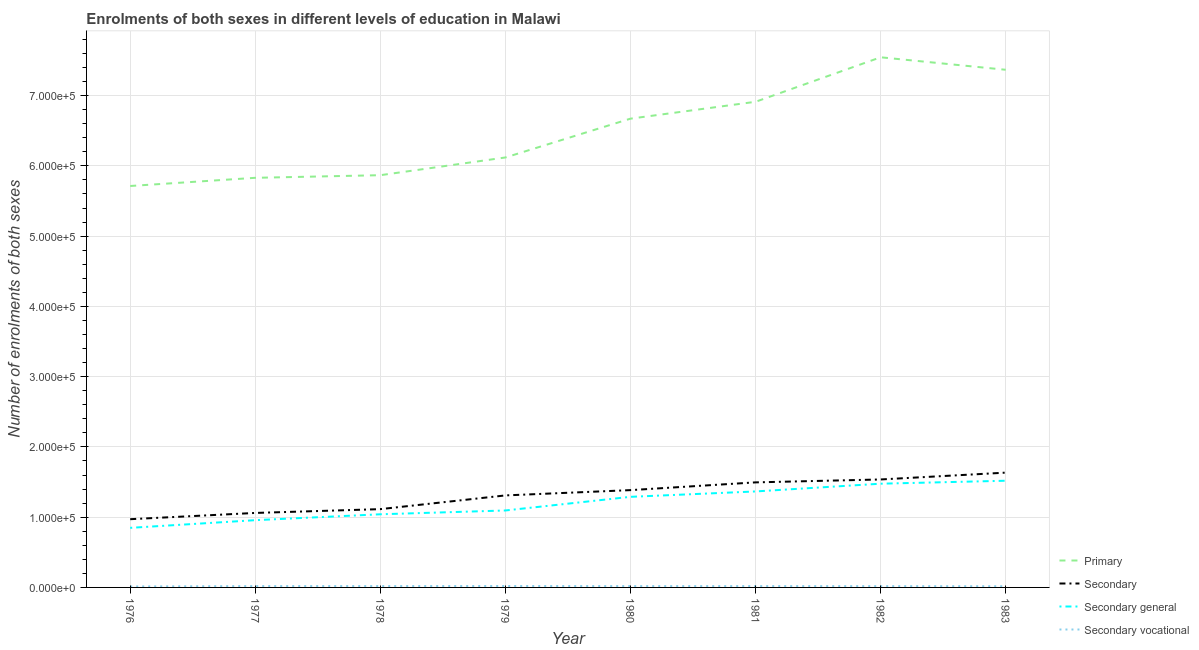Is the number of lines equal to the number of legend labels?
Provide a short and direct response. Yes. What is the number of enrolments in primary education in 1982?
Give a very brief answer. 7.55e+05. Across all years, what is the maximum number of enrolments in secondary general education?
Your response must be concise. 1.52e+05. Across all years, what is the minimum number of enrolments in secondary vocational education?
Provide a succinct answer. 1392. In which year was the number of enrolments in secondary education maximum?
Make the answer very short. 1983. In which year was the number of enrolments in secondary education minimum?
Your response must be concise. 1976. What is the total number of enrolments in secondary general education in the graph?
Offer a very short reply. 9.59e+05. What is the difference between the number of enrolments in secondary vocational education in 1980 and that in 1983?
Your response must be concise. 187. What is the difference between the number of enrolments in secondary general education in 1982 and the number of enrolments in secondary education in 1976?
Your answer should be compact. 5.05e+04. What is the average number of enrolments in secondary education per year?
Your answer should be very brief. 1.31e+05. In the year 1978, what is the difference between the number of enrolments in primary education and number of enrolments in secondary general education?
Provide a short and direct response. 4.83e+05. What is the ratio of the number of enrolments in secondary vocational education in 1977 to that in 1979?
Ensure brevity in your answer.  0.94. Is the number of enrolments in primary education in 1977 less than that in 1981?
Provide a succinct answer. Yes. What is the difference between the highest and the second highest number of enrolments in secondary vocational education?
Give a very brief answer. 108. What is the difference between the highest and the lowest number of enrolments in secondary general education?
Keep it short and to the point. 6.71e+04. In how many years, is the number of enrolments in primary education greater than the average number of enrolments in primary education taken over all years?
Ensure brevity in your answer.  4. Is the sum of the number of enrolments in secondary education in 1976 and 1982 greater than the maximum number of enrolments in secondary vocational education across all years?
Offer a very short reply. Yes. Is it the case that in every year, the sum of the number of enrolments in primary education and number of enrolments in secondary education is greater than the number of enrolments in secondary general education?
Your answer should be very brief. Yes. Does the number of enrolments in secondary education monotonically increase over the years?
Your answer should be compact. Yes. How many lines are there?
Your answer should be very brief. 4. How many years are there in the graph?
Your answer should be compact. 8. Does the graph contain any zero values?
Your response must be concise. No. How many legend labels are there?
Your response must be concise. 4. What is the title of the graph?
Your answer should be compact. Enrolments of both sexes in different levels of education in Malawi. Does "Overall level" appear as one of the legend labels in the graph?
Make the answer very short. No. What is the label or title of the Y-axis?
Make the answer very short. Number of enrolments of both sexes. What is the Number of enrolments of both sexes in Primary in 1976?
Offer a very short reply. 5.71e+05. What is the Number of enrolments of both sexes in Secondary in 1976?
Keep it short and to the point. 9.71e+04. What is the Number of enrolments of both sexes of Secondary general in 1976?
Offer a very short reply. 8.48e+04. What is the Number of enrolments of both sexes in Secondary vocational in 1976?
Provide a short and direct response. 1392. What is the Number of enrolments of both sexes of Primary in 1977?
Offer a very short reply. 5.83e+05. What is the Number of enrolments of both sexes in Secondary in 1977?
Your answer should be compact. 1.06e+05. What is the Number of enrolments of both sexes in Secondary general in 1977?
Your answer should be very brief. 9.57e+04. What is the Number of enrolments of both sexes in Secondary vocational in 1977?
Your response must be concise. 1905. What is the Number of enrolments of both sexes of Primary in 1978?
Give a very brief answer. 5.87e+05. What is the Number of enrolments of both sexes of Secondary in 1978?
Offer a terse response. 1.11e+05. What is the Number of enrolments of both sexes in Secondary general in 1978?
Your answer should be compact. 1.04e+05. What is the Number of enrolments of both sexes of Secondary vocational in 1978?
Your answer should be very brief. 1915. What is the Number of enrolments of both sexes of Primary in 1979?
Provide a succinct answer. 6.12e+05. What is the Number of enrolments of both sexes in Secondary in 1979?
Make the answer very short. 1.31e+05. What is the Number of enrolments of both sexes in Secondary general in 1979?
Your response must be concise. 1.10e+05. What is the Number of enrolments of both sexes of Secondary vocational in 1979?
Provide a succinct answer. 2023. What is the Number of enrolments of both sexes of Primary in 1980?
Keep it short and to the point. 6.67e+05. What is the Number of enrolments of both sexes of Secondary in 1980?
Make the answer very short. 1.38e+05. What is the Number of enrolments of both sexes in Secondary general in 1980?
Keep it short and to the point. 1.29e+05. What is the Number of enrolments of both sexes of Secondary vocational in 1980?
Provide a succinct answer. 1875. What is the Number of enrolments of both sexes in Primary in 1981?
Give a very brief answer. 6.91e+05. What is the Number of enrolments of both sexes in Secondary in 1981?
Offer a very short reply. 1.50e+05. What is the Number of enrolments of both sexes of Secondary general in 1981?
Keep it short and to the point. 1.37e+05. What is the Number of enrolments of both sexes in Secondary vocational in 1981?
Provide a succinct answer. 1888. What is the Number of enrolments of both sexes of Primary in 1982?
Your response must be concise. 7.55e+05. What is the Number of enrolments of both sexes in Secondary in 1982?
Offer a terse response. 1.54e+05. What is the Number of enrolments of both sexes in Secondary general in 1982?
Keep it short and to the point. 1.48e+05. What is the Number of enrolments of both sexes of Secondary vocational in 1982?
Provide a succinct answer. 1814. What is the Number of enrolments of both sexes of Primary in 1983?
Offer a terse response. 7.37e+05. What is the Number of enrolments of both sexes in Secondary in 1983?
Ensure brevity in your answer.  1.63e+05. What is the Number of enrolments of both sexes in Secondary general in 1983?
Your answer should be compact. 1.52e+05. What is the Number of enrolments of both sexes of Secondary vocational in 1983?
Provide a short and direct response. 1688. Across all years, what is the maximum Number of enrolments of both sexes of Primary?
Your response must be concise. 7.55e+05. Across all years, what is the maximum Number of enrolments of both sexes of Secondary?
Your answer should be very brief. 1.63e+05. Across all years, what is the maximum Number of enrolments of both sexes of Secondary general?
Ensure brevity in your answer.  1.52e+05. Across all years, what is the maximum Number of enrolments of both sexes of Secondary vocational?
Provide a short and direct response. 2023. Across all years, what is the minimum Number of enrolments of both sexes of Primary?
Give a very brief answer. 5.71e+05. Across all years, what is the minimum Number of enrolments of both sexes in Secondary?
Ensure brevity in your answer.  9.71e+04. Across all years, what is the minimum Number of enrolments of both sexes of Secondary general?
Provide a succinct answer. 8.48e+04. Across all years, what is the minimum Number of enrolments of both sexes of Secondary vocational?
Your response must be concise. 1392. What is the total Number of enrolments of both sexes in Primary in the graph?
Provide a short and direct response. 5.20e+06. What is the total Number of enrolments of both sexes in Secondary in the graph?
Provide a short and direct response. 1.05e+06. What is the total Number of enrolments of both sexes in Secondary general in the graph?
Provide a succinct answer. 9.59e+05. What is the total Number of enrolments of both sexes of Secondary vocational in the graph?
Offer a terse response. 1.45e+04. What is the difference between the Number of enrolments of both sexes of Primary in 1976 and that in 1977?
Offer a very short reply. -1.16e+04. What is the difference between the Number of enrolments of both sexes of Secondary in 1976 and that in 1977?
Your response must be concise. -8907. What is the difference between the Number of enrolments of both sexes of Secondary general in 1976 and that in 1977?
Keep it short and to the point. -1.09e+04. What is the difference between the Number of enrolments of both sexes of Secondary vocational in 1976 and that in 1977?
Ensure brevity in your answer.  -513. What is the difference between the Number of enrolments of both sexes in Primary in 1976 and that in 1978?
Offer a terse response. -1.54e+04. What is the difference between the Number of enrolments of both sexes of Secondary in 1976 and that in 1978?
Ensure brevity in your answer.  -1.43e+04. What is the difference between the Number of enrolments of both sexes in Secondary general in 1976 and that in 1978?
Offer a terse response. -1.93e+04. What is the difference between the Number of enrolments of both sexes in Secondary vocational in 1976 and that in 1978?
Give a very brief answer. -523. What is the difference between the Number of enrolments of both sexes in Primary in 1976 and that in 1979?
Provide a short and direct response. -4.06e+04. What is the difference between the Number of enrolments of both sexes in Secondary in 1976 and that in 1979?
Make the answer very short. -3.39e+04. What is the difference between the Number of enrolments of both sexes of Secondary general in 1976 and that in 1979?
Keep it short and to the point. -2.47e+04. What is the difference between the Number of enrolments of both sexes in Secondary vocational in 1976 and that in 1979?
Ensure brevity in your answer.  -631. What is the difference between the Number of enrolments of both sexes in Primary in 1976 and that in 1980?
Offer a terse response. -9.58e+04. What is the difference between the Number of enrolments of both sexes in Secondary in 1976 and that in 1980?
Ensure brevity in your answer.  -4.14e+04. What is the difference between the Number of enrolments of both sexes of Secondary general in 1976 and that in 1980?
Offer a terse response. -4.41e+04. What is the difference between the Number of enrolments of both sexes in Secondary vocational in 1976 and that in 1980?
Make the answer very short. -483. What is the difference between the Number of enrolments of both sexes of Primary in 1976 and that in 1981?
Your response must be concise. -1.20e+05. What is the difference between the Number of enrolments of both sexes of Secondary in 1976 and that in 1981?
Your response must be concise. -5.24e+04. What is the difference between the Number of enrolments of both sexes of Secondary general in 1976 and that in 1981?
Your response must be concise. -5.18e+04. What is the difference between the Number of enrolments of both sexes in Secondary vocational in 1976 and that in 1981?
Your answer should be very brief. -496. What is the difference between the Number of enrolments of both sexes of Primary in 1976 and that in 1982?
Provide a short and direct response. -1.83e+05. What is the difference between the Number of enrolments of both sexes in Secondary in 1976 and that in 1982?
Offer a terse response. -5.66e+04. What is the difference between the Number of enrolments of both sexes in Secondary general in 1976 and that in 1982?
Keep it short and to the point. -6.28e+04. What is the difference between the Number of enrolments of both sexes of Secondary vocational in 1976 and that in 1982?
Make the answer very short. -422. What is the difference between the Number of enrolments of both sexes of Primary in 1976 and that in 1983?
Keep it short and to the point. -1.65e+05. What is the difference between the Number of enrolments of both sexes in Secondary in 1976 and that in 1983?
Keep it short and to the point. -6.63e+04. What is the difference between the Number of enrolments of both sexes of Secondary general in 1976 and that in 1983?
Ensure brevity in your answer.  -6.71e+04. What is the difference between the Number of enrolments of both sexes in Secondary vocational in 1976 and that in 1983?
Your response must be concise. -296. What is the difference between the Number of enrolments of both sexes of Primary in 1977 and that in 1978?
Your answer should be very brief. -3720. What is the difference between the Number of enrolments of both sexes in Secondary in 1977 and that in 1978?
Provide a short and direct response. -5421. What is the difference between the Number of enrolments of both sexes in Secondary general in 1977 and that in 1978?
Offer a very short reply. -8394. What is the difference between the Number of enrolments of both sexes in Primary in 1977 and that in 1979?
Offer a terse response. -2.89e+04. What is the difference between the Number of enrolments of both sexes of Secondary in 1977 and that in 1979?
Provide a short and direct response. -2.49e+04. What is the difference between the Number of enrolments of both sexes of Secondary general in 1977 and that in 1979?
Your answer should be compact. -1.38e+04. What is the difference between the Number of enrolments of both sexes in Secondary vocational in 1977 and that in 1979?
Keep it short and to the point. -118. What is the difference between the Number of enrolments of both sexes of Primary in 1977 and that in 1980?
Offer a very short reply. -8.42e+04. What is the difference between the Number of enrolments of both sexes in Secondary in 1977 and that in 1980?
Offer a very short reply. -3.25e+04. What is the difference between the Number of enrolments of both sexes in Secondary general in 1977 and that in 1980?
Your answer should be very brief. -3.32e+04. What is the difference between the Number of enrolments of both sexes of Primary in 1977 and that in 1981?
Make the answer very short. -1.08e+05. What is the difference between the Number of enrolments of both sexes in Secondary in 1977 and that in 1981?
Make the answer very short. -4.35e+04. What is the difference between the Number of enrolments of both sexes in Secondary general in 1977 and that in 1981?
Keep it short and to the point. -4.09e+04. What is the difference between the Number of enrolments of both sexes of Secondary vocational in 1977 and that in 1981?
Ensure brevity in your answer.  17. What is the difference between the Number of enrolments of both sexes in Primary in 1977 and that in 1982?
Offer a very short reply. -1.72e+05. What is the difference between the Number of enrolments of both sexes in Secondary in 1977 and that in 1982?
Give a very brief answer. -4.77e+04. What is the difference between the Number of enrolments of both sexes in Secondary general in 1977 and that in 1982?
Your response must be concise. -5.19e+04. What is the difference between the Number of enrolments of both sexes in Secondary vocational in 1977 and that in 1982?
Offer a terse response. 91. What is the difference between the Number of enrolments of both sexes of Primary in 1977 and that in 1983?
Your response must be concise. -1.54e+05. What is the difference between the Number of enrolments of both sexes in Secondary in 1977 and that in 1983?
Your answer should be compact. -5.74e+04. What is the difference between the Number of enrolments of both sexes of Secondary general in 1977 and that in 1983?
Provide a succinct answer. -5.61e+04. What is the difference between the Number of enrolments of both sexes in Secondary vocational in 1977 and that in 1983?
Your answer should be very brief. 217. What is the difference between the Number of enrolments of both sexes in Primary in 1978 and that in 1979?
Your answer should be compact. -2.52e+04. What is the difference between the Number of enrolments of both sexes of Secondary in 1978 and that in 1979?
Your response must be concise. -1.95e+04. What is the difference between the Number of enrolments of both sexes in Secondary general in 1978 and that in 1979?
Give a very brief answer. -5411. What is the difference between the Number of enrolments of both sexes in Secondary vocational in 1978 and that in 1979?
Your answer should be compact. -108. What is the difference between the Number of enrolments of both sexes in Primary in 1978 and that in 1980?
Provide a succinct answer. -8.05e+04. What is the difference between the Number of enrolments of both sexes of Secondary in 1978 and that in 1980?
Your response must be concise. -2.71e+04. What is the difference between the Number of enrolments of both sexes of Secondary general in 1978 and that in 1980?
Keep it short and to the point. -2.48e+04. What is the difference between the Number of enrolments of both sexes of Secondary vocational in 1978 and that in 1980?
Your answer should be very brief. 40. What is the difference between the Number of enrolments of both sexes of Primary in 1978 and that in 1981?
Offer a terse response. -1.04e+05. What is the difference between the Number of enrolments of both sexes in Secondary in 1978 and that in 1981?
Provide a succinct answer. -3.81e+04. What is the difference between the Number of enrolments of both sexes in Secondary general in 1978 and that in 1981?
Keep it short and to the point. -3.25e+04. What is the difference between the Number of enrolments of both sexes of Secondary vocational in 1978 and that in 1981?
Give a very brief answer. 27. What is the difference between the Number of enrolments of both sexes of Primary in 1978 and that in 1982?
Your answer should be very brief. -1.68e+05. What is the difference between the Number of enrolments of both sexes of Secondary in 1978 and that in 1982?
Offer a very short reply. -4.22e+04. What is the difference between the Number of enrolments of both sexes in Secondary general in 1978 and that in 1982?
Ensure brevity in your answer.  -4.35e+04. What is the difference between the Number of enrolments of both sexes in Secondary vocational in 1978 and that in 1982?
Your answer should be compact. 101. What is the difference between the Number of enrolments of both sexes in Primary in 1978 and that in 1983?
Make the answer very short. -1.50e+05. What is the difference between the Number of enrolments of both sexes of Secondary in 1978 and that in 1983?
Make the answer very short. -5.19e+04. What is the difference between the Number of enrolments of both sexes in Secondary general in 1978 and that in 1983?
Offer a very short reply. -4.77e+04. What is the difference between the Number of enrolments of both sexes of Secondary vocational in 1978 and that in 1983?
Make the answer very short. 227. What is the difference between the Number of enrolments of both sexes in Primary in 1979 and that in 1980?
Your answer should be very brief. -5.52e+04. What is the difference between the Number of enrolments of both sexes in Secondary in 1979 and that in 1980?
Give a very brief answer. -7523. What is the difference between the Number of enrolments of both sexes of Secondary general in 1979 and that in 1980?
Your response must be concise. -1.94e+04. What is the difference between the Number of enrolments of both sexes in Secondary vocational in 1979 and that in 1980?
Your response must be concise. 148. What is the difference between the Number of enrolments of both sexes of Primary in 1979 and that in 1981?
Your response must be concise. -7.93e+04. What is the difference between the Number of enrolments of both sexes in Secondary in 1979 and that in 1981?
Your response must be concise. -1.86e+04. What is the difference between the Number of enrolments of both sexes of Secondary general in 1979 and that in 1981?
Provide a succinct answer. -2.71e+04. What is the difference between the Number of enrolments of both sexes in Secondary vocational in 1979 and that in 1981?
Offer a very short reply. 135. What is the difference between the Number of enrolments of both sexes in Primary in 1979 and that in 1982?
Ensure brevity in your answer.  -1.43e+05. What is the difference between the Number of enrolments of both sexes of Secondary in 1979 and that in 1982?
Provide a short and direct response. -2.27e+04. What is the difference between the Number of enrolments of both sexes in Secondary general in 1979 and that in 1982?
Keep it short and to the point. -3.81e+04. What is the difference between the Number of enrolments of both sexes of Secondary vocational in 1979 and that in 1982?
Give a very brief answer. 209. What is the difference between the Number of enrolments of both sexes of Primary in 1979 and that in 1983?
Make the answer very short. -1.25e+05. What is the difference between the Number of enrolments of both sexes in Secondary in 1979 and that in 1983?
Ensure brevity in your answer.  -3.24e+04. What is the difference between the Number of enrolments of both sexes of Secondary general in 1979 and that in 1983?
Provide a succinct answer. -4.23e+04. What is the difference between the Number of enrolments of both sexes of Secondary vocational in 1979 and that in 1983?
Offer a terse response. 335. What is the difference between the Number of enrolments of both sexes of Primary in 1980 and that in 1981?
Offer a very short reply. -2.40e+04. What is the difference between the Number of enrolments of both sexes of Secondary in 1980 and that in 1981?
Your answer should be very brief. -1.10e+04. What is the difference between the Number of enrolments of both sexes in Secondary general in 1980 and that in 1981?
Provide a succinct answer. -7671. What is the difference between the Number of enrolments of both sexes in Primary in 1980 and that in 1982?
Your answer should be very brief. -8.74e+04. What is the difference between the Number of enrolments of both sexes in Secondary in 1980 and that in 1982?
Keep it short and to the point. -1.52e+04. What is the difference between the Number of enrolments of both sexes in Secondary general in 1980 and that in 1982?
Your response must be concise. -1.87e+04. What is the difference between the Number of enrolments of both sexes in Primary in 1980 and that in 1983?
Your answer should be very brief. -6.96e+04. What is the difference between the Number of enrolments of both sexes in Secondary in 1980 and that in 1983?
Your answer should be compact. -2.49e+04. What is the difference between the Number of enrolments of both sexes of Secondary general in 1980 and that in 1983?
Ensure brevity in your answer.  -2.29e+04. What is the difference between the Number of enrolments of both sexes in Secondary vocational in 1980 and that in 1983?
Provide a succinct answer. 187. What is the difference between the Number of enrolments of both sexes of Primary in 1981 and that in 1982?
Ensure brevity in your answer.  -6.33e+04. What is the difference between the Number of enrolments of both sexes of Secondary in 1981 and that in 1982?
Ensure brevity in your answer.  -4147. What is the difference between the Number of enrolments of both sexes in Secondary general in 1981 and that in 1982?
Offer a terse response. -1.10e+04. What is the difference between the Number of enrolments of both sexes in Secondary vocational in 1981 and that in 1982?
Your response must be concise. 74. What is the difference between the Number of enrolments of both sexes of Primary in 1981 and that in 1983?
Ensure brevity in your answer.  -4.56e+04. What is the difference between the Number of enrolments of both sexes in Secondary in 1981 and that in 1983?
Your answer should be compact. -1.39e+04. What is the difference between the Number of enrolments of both sexes in Secondary general in 1981 and that in 1983?
Ensure brevity in your answer.  -1.52e+04. What is the difference between the Number of enrolments of both sexes in Secondary vocational in 1981 and that in 1983?
Provide a short and direct response. 200. What is the difference between the Number of enrolments of both sexes of Primary in 1982 and that in 1983?
Your response must be concise. 1.78e+04. What is the difference between the Number of enrolments of both sexes in Secondary in 1982 and that in 1983?
Your answer should be very brief. -9712. What is the difference between the Number of enrolments of both sexes of Secondary general in 1982 and that in 1983?
Provide a short and direct response. -4221. What is the difference between the Number of enrolments of both sexes of Secondary vocational in 1982 and that in 1983?
Make the answer very short. 126. What is the difference between the Number of enrolments of both sexes of Primary in 1976 and the Number of enrolments of both sexes of Secondary in 1977?
Offer a terse response. 4.65e+05. What is the difference between the Number of enrolments of both sexes in Primary in 1976 and the Number of enrolments of both sexes in Secondary general in 1977?
Ensure brevity in your answer.  4.76e+05. What is the difference between the Number of enrolments of both sexes in Primary in 1976 and the Number of enrolments of both sexes in Secondary vocational in 1977?
Your response must be concise. 5.69e+05. What is the difference between the Number of enrolments of both sexes of Secondary in 1976 and the Number of enrolments of both sexes of Secondary general in 1977?
Offer a terse response. 1392. What is the difference between the Number of enrolments of both sexes in Secondary in 1976 and the Number of enrolments of both sexes in Secondary vocational in 1977?
Your answer should be very brief. 9.52e+04. What is the difference between the Number of enrolments of both sexes in Secondary general in 1976 and the Number of enrolments of both sexes in Secondary vocational in 1977?
Offer a terse response. 8.29e+04. What is the difference between the Number of enrolments of both sexes in Primary in 1976 and the Number of enrolments of both sexes in Secondary in 1978?
Provide a succinct answer. 4.60e+05. What is the difference between the Number of enrolments of both sexes in Primary in 1976 and the Number of enrolments of both sexes in Secondary general in 1978?
Provide a short and direct response. 4.67e+05. What is the difference between the Number of enrolments of both sexes in Primary in 1976 and the Number of enrolments of both sexes in Secondary vocational in 1978?
Offer a terse response. 5.69e+05. What is the difference between the Number of enrolments of both sexes of Secondary in 1976 and the Number of enrolments of both sexes of Secondary general in 1978?
Your answer should be compact. -7002. What is the difference between the Number of enrolments of both sexes of Secondary in 1976 and the Number of enrolments of both sexes of Secondary vocational in 1978?
Ensure brevity in your answer.  9.52e+04. What is the difference between the Number of enrolments of both sexes in Secondary general in 1976 and the Number of enrolments of both sexes in Secondary vocational in 1978?
Offer a very short reply. 8.29e+04. What is the difference between the Number of enrolments of both sexes of Primary in 1976 and the Number of enrolments of both sexes of Secondary in 1979?
Make the answer very short. 4.40e+05. What is the difference between the Number of enrolments of both sexes in Primary in 1976 and the Number of enrolments of both sexes in Secondary general in 1979?
Provide a succinct answer. 4.62e+05. What is the difference between the Number of enrolments of both sexes of Primary in 1976 and the Number of enrolments of both sexes of Secondary vocational in 1979?
Your answer should be very brief. 5.69e+05. What is the difference between the Number of enrolments of both sexes in Secondary in 1976 and the Number of enrolments of both sexes in Secondary general in 1979?
Your answer should be compact. -1.24e+04. What is the difference between the Number of enrolments of both sexes in Secondary in 1976 and the Number of enrolments of both sexes in Secondary vocational in 1979?
Offer a terse response. 9.51e+04. What is the difference between the Number of enrolments of both sexes of Secondary general in 1976 and the Number of enrolments of both sexes of Secondary vocational in 1979?
Offer a terse response. 8.28e+04. What is the difference between the Number of enrolments of both sexes of Primary in 1976 and the Number of enrolments of both sexes of Secondary in 1980?
Provide a short and direct response. 4.33e+05. What is the difference between the Number of enrolments of both sexes of Primary in 1976 and the Number of enrolments of both sexes of Secondary general in 1980?
Provide a short and direct response. 4.42e+05. What is the difference between the Number of enrolments of both sexes in Primary in 1976 and the Number of enrolments of both sexes in Secondary vocational in 1980?
Give a very brief answer. 5.70e+05. What is the difference between the Number of enrolments of both sexes of Secondary in 1976 and the Number of enrolments of both sexes of Secondary general in 1980?
Your answer should be compact. -3.18e+04. What is the difference between the Number of enrolments of both sexes of Secondary in 1976 and the Number of enrolments of both sexes of Secondary vocational in 1980?
Your answer should be compact. 9.52e+04. What is the difference between the Number of enrolments of both sexes of Secondary general in 1976 and the Number of enrolments of both sexes of Secondary vocational in 1980?
Offer a very short reply. 8.29e+04. What is the difference between the Number of enrolments of both sexes of Primary in 1976 and the Number of enrolments of both sexes of Secondary in 1981?
Keep it short and to the point. 4.22e+05. What is the difference between the Number of enrolments of both sexes in Primary in 1976 and the Number of enrolments of both sexes in Secondary general in 1981?
Offer a very short reply. 4.35e+05. What is the difference between the Number of enrolments of both sexes of Primary in 1976 and the Number of enrolments of both sexes of Secondary vocational in 1981?
Offer a terse response. 5.70e+05. What is the difference between the Number of enrolments of both sexes in Secondary in 1976 and the Number of enrolments of both sexes in Secondary general in 1981?
Your response must be concise. -3.95e+04. What is the difference between the Number of enrolments of both sexes of Secondary in 1976 and the Number of enrolments of both sexes of Secondary vocational in 1981?
Ensure brevity in your answer.  9.52e+04. What is the difference between the Number of enrolments of both sexes in Secondary general in 1976 and the Number of enrolments of both sexes in Secondary vocational in 1981?
Keep it short and to the point. 8.29e+04. What is the difference between the Number of enrolments of both sexes of Primary in 1976 and the Number of enrolments of both sexes of Secondary in 1982?
Keep it short and to the point. 4.18e+05. What is the difference between the Number of enrolments of both sexes of Primary in 1976 and the Number of enrolments of both sexes of Secondary general in 1982?
Ensure brevity in your answer.  4.24e+05. What is the difference between the Number of enrolments of both sexes in Primary in 1976 and the Number of enrolments of both sexes in Secondary vocational in 1982?
Offer a terse response. 5.70e+05. What is the difference between the Number of enrolments of both sexes of Secondary in 1976 and the Number of enrolments of both sexes of Secondary general in 1982?
Make the answer very short. -5.05e+04. What is the difference between the Number of enrolments of both sexes of Secondary in 1976 and the Number of enrolments of both sexes of Secondary vocational in 1982?
Provide a succinct answer. 9.53e+04. What is the difference between the Number of enrolments of both sexes in Secondary general in 1976 and the Number of enrolments of both sexes in Secondary vocational in 1982?
Provide a short and direct response. 8.30e+04. What is the difference between the Number of enrolments of both sexes in Primary in 1976 and the Number of enrolments of both sexes in Secondary in 1983?
Your response must be concise. 4.08e+05. What is the difference between the Number of enrolments of both sexes of Primary in 1976 and the Number of enrolments of both sexes of Secondary general in 1983?
Your response must be concise. 4.20e+05. What is the difference between the Number of enrolments of both sexes of Primary in 1976 and the Number of enrolments of both sexes of Secondary vocational in 1983?
Ensure brevity in your answer.  5.70e+05. What is the difference between the Number of enrolments of both sexes of Secondary in 1976 and the Number of enrolments of both sexes of Secondary general in 1983?
Make the answer very short. -5.47e+04. What is the difference between the Number of enrolments of both sexes in Secondary in 1976 and the Number of enrolments of both sexes in Secondary vocational in 1983?
Keep it short and to the point. 9.54e+04. What is the difference between the Number of enrolments of both sexes of Secondary general in 1976 and the Number of enrolments of both sexes of Secondary vocational in 1983?
Offer a very short reply. 8.31e+04. What is the difference between the Number of enrolments of both sexes in Primary in 1977 and the Number of enrolments of both sexes in Secondary in 1978?
Provide a short and direct response. 4.72e+05. What is the difference between the Number of enrolments of both sexes of Primary in 1977 and the Number of enrolments of both sexes of Secondary general in 1978?
Give a very brief answer. 4.79e+05. What is the difference between the Number of enrolments of both sexes of Primary in 1977 and the Number of enrolments of both sexes of Secondary vocational in 1978?
Make the answer very short. 5.81e+05. What is the difference between the Number of enrolments of both sexes of Secondary in 1977 and the Number of enrolments of both sexes of Secondary general in 1978?
Offer a terse response. 1905. What is the difference between the Number of enrolments of both sexes of Secondary in 1977 and the Number of enrolments of both sexes of Secondary vocational in 1978?
Give a very brief answer. 1.04e+05. What is the difference between the Number of enrolments of both sexes in Secondary general in 1977 and the Number of enrolments of both sexes in Secondary vocational in 1978?
Give a very brief answer. 9.38e+04. What is the difference between the Number of enrolments of both sexes of Primary in 1977 and the Number of enrolments of both sexes of Secondary in 1979?
Your answer should be very brief. 4.52e+05. What is the difference between the Number of enrolments of both sexes in Primary in 1977 and the Number of enrolments of both sexes in Secondary general in 1979?
Provide a succinct answer. 4.74e+05. What is the difference between the Number of enrolments of both sexes in Primary in 1977 and the Number of enrolments of both sexes in Secondary vocational in 1979?
Your answer should be very brief. 5.81e+05. What is the difference between the Number of enrolments of both sexes in Secondary in 1977 and the Number of enrolments of both sexes in Secondary general in 1979?
Your answer should be very brief. -3506. What is the difference between the Number of enrolments of both sexes in Secondary in 1977 and the Number of enrolments of both sexes in Secondary vocational in 1979?
Your answer should be very brief. 1.04e+05. What is the difference between the Number of enrolments of both sexes of Secondary general in 1977 and the Number of enrolments of both sexes of Secondary vocational in 1979?
Offer a terse response. 9.37e+04. What is the difference between the Number of enrolments of both sexes of Primary in 1977 and the Number of enrolments of both sexes of Secondary in 1980?
Keep it short and to the point. 4.45e+05. What is the difference between the Number of enrolments of both sexes of Primary in 1977 and the Number of enrolments of both sexes of Secondary general in 1980?
Your answer should be very brief. 4.54e+05. What is the difference between the Number of enrolments of both sexes in Primary in 1977 and the Number of enrolments of both sexes in Secondary vocational in 1980?
Provide a succinct answer. 5.81e+05. What is the difference between the Number of enrolments of both sexes of Secondary in 1977 and the Number of enrolments of both sexes of Secondary general in 1980?
Ensure brevity in your answer.  -2.29e+04. What is the difference between the Number of enrolments of both sexes of Secondary in 1977 and the Number of enrolments of both sexes of Secondary vocational in 1980?
Make the answer very short. 1.04e+05. What is the difference between the Number of enrolments of both sexes in Secondary general in 1977 and the Number of enrolments of both sexes in Secondary vocational in 1980?
Make the answer very short. 9.39e+04. What is the difference between the Number of enrolments of both sexes in Primary in 1977 and the Number of enrolments of both sexes in Secondary in 1981?
Offer a very short reply. 4.34e+05. What is the difference between the Number of enrolments of both sexes of Primary in 1977 and the Number of enrolments of both sexes of Secondary general in 1981?
Ensure brevity in your answer.  4.46e+05. What is the difference between the Number of enrolments of both sexes in Primary in 1977 and the Number of enrolments of both sexes in Secondary vocational in 1981?
Make the answer very short. 5.81e+05. What is the difference between the Number of enrolments of both sexes in Secondary in 1977 and the Number of enrolments of both sexes in Secondary general in 1981?
Make the answer very short. -3.06e+04. What is the difference between the Number of enrolments of both sexes in Secondary in 1977 and the Number of enrolments of both sexes in Secondary vocational in 1981?
Your response must be concise. 1.04e+05. What is the difference between the Number of enrolments of both sexes in Secondary general in 1977 and the Number of enrolments of both sexes in Secondary vocational in 1981?
Make the answer very short. 9.38e+04. What is the difference between the Number of enrolments of both sexes of Primary in 1977 and the Number of enrolments of both sexes of Secondary in 1982?
Your response must be concise. 4.29e+05. What is the difference between the Number of enrolments of both sexes in Primary in 1977 and the Number of enrolments of both sexes in Secondary general in 1982?
Offer a terse response. 4.35e+05. What is the difference between the Number of enrolments of both sexes in Primary in 1977 and the Number of enrolments of both sexes in Secondary vocational in 1982?
Your answer should be compact. 5.81e+05. What is the difference between the Number of enrolments of both sexes in Secondary in 1977 and the Number of enrolments of both sexes in Secondary general in 1982?
Offer a terse response. -4.16e+04. What is the difference between the Number of enrolments of both sexes of Secondary in 1977 and the Number of enrolments of both sexes of Secondary vocational in 1982?
Provide a short and direct response. 1.04e+05. What is the difference between the Number of enrolments of both sexes of Secondary general in 1977 and the Number of enrolments of both sexes of Secondary vocational in 1982?
Give a very brief answer. 9.39e+04. What is the difference between the Number of enrolments of both sexes of Primary in 1977 and the Number of enrolments of both sexes of Secondary in 1983?
Offer a very short reply. 4.20e+05. What is the difference between the Number of enrolments of both sexes of Primary in 1977 and the Number of enrolments of both sexes of Secondary general in 1983?
Offer a very short reply. 4.31e+05. What is the difference between the Number of enrolments of both sexes of Primary in 1977 and the Number of enrolments of both sexes of Secondary vocational in 1983?
Your response must be concise. 5.81e+05. What is the difference between the Number of enrolments of both sexes of Secondary in 1977 and the Number of enrolments of both sexes of Secondary general in 1983?
Give a very brief answer. -4.58e+04. What is the difference between the Number of enrolments of both sexes in Secondary in 1977 and the Number of enrolments of both sexes in Secondary vocational in 1983?
Offer a terse response. 1.04e+05. What is the difference between the Number of enrolments of both sexes in Secondary general in 1977 and the Number of enrolments of both sexes in Secondary vocational in 1983?
Offer a very short reply. 9.40e+04. What is the difference between the Number of enrolments of both sexes in Primary in 1978 and the Number of enrolments of both sexes in Secondary in 1979?
Provide a short and direct response. 4.56e+05. What is the difference between the Number of enrolments of both sexes of Primary in 1978 and the Number of enrolments of both sexes of Secondary general in 1979?
Keep it short and to the point. 4.77e+05. What is the difference between the Number of enrolments of both sexes in Primary in 1978 and the Number of enrolments of both sexes in Secondary vocational in 1979?
Provide a succinct answer. 5.85e+05. What is the difference between the Number of enrolments of both sexes in Secondary in 1978 and the Number of enrolments of both sexes in Secondary general in 1979?
Your response must be concise. 1915. What is the difference between the Number of enrolments of both sexes of Secondary in 1978 and the Number of enrolments of both sexes of Secondary vocational in 1979?
Your answer should be compact. 1.09e+05. What is the difference between the Number of enrolments of both sexes in Secondary general in 1978 and the Number of enrolments of both sexes in Secondary vocational in 1979?
Give a very brief answer. 1.02e+05. What is the difference between the Number of enrolments of both sexes in Primary in 1978 and the Number of enrolments of both sexes in Secondary in 1980?
Your answer should be compact. 4.48e+05. What is the difference between the Number of enrolments of both sexes of Primary in 1978 and the Number of enrolments of both sexes of Secondary general in 1980?
Provide a succinct answer. 4.58e+05. What is the difference between the Number of enrolments of both sexes of Primary in 1978 and the Number of enrolments of both sexes of Secondary vocational in 1980?
Offer a terse response. 5.85e+05. What is the difference between the Number of enrolments of both sexes of Secondary in 1978 and the Number of enrolments of both sexes of Secondary general in 1980?
Your answer should be very brief. -1.75e+04. What is the difference between the Number of enrolments of both sexes in Secondary in 1978 and the Number of enrolments of both sexes in Secondary vocational in 1980?
Your response must be concise. 1.10e+05. What is the difference between the Number of enrolments of both sexes of Secondary general in 1978 and the Number of enrolments of both sexes of Secondary vocational in 1980?
Provide a succinct answer. 1.02e+05. What is the difference between the Number of enrolments of both sexes of Primary in 1978 and the Number of enrolments of both sexes of Secondary in 1981?
Your answer should be compact. 4.37e+05. What is the difference between the Number of enrolments of both sexes in Primary in 1978 and the Number of enrolments of both sexes in Secondary general in 1981?
Ensure brevity in your answer.  4.50e+05. What is the difference between the Number of enrolments of both sexes in Primary in 1978 and the Number of enrolments of both sexes in Secondary vocational in 1981?
Offer a terse response. 5.85e+05. What is the difference between the Number of enrolments of both sexes in Secondary in 1978 and the Number of enrolments of both sexes in Secondary general in 1981?
Keep it short and to the point. -2.52e+04. What is the difference between the Number of enrolments of both sexes of Secondary in 1978 and the Number of enrolments of both sexes of Secondary vocational in 1981?
Provide a short and direct response. 1.10e+05. What is the difference between the Number of enrolments of both sexes in Secondary general in 1978 and the Number of enrolments of both sexes in Secondary vocational in 1981?
Keep it short and to the point. 1.02e+05. What is the difference between the Number of enrolments of both sexes in Primary in 1978 and the Number of enrolments of both sexes in Secondary in 1982?
Your answer should be very brief. 4.33e+05. What is the difference between the Number of enrolments of both sexes of Primary in 1978 and the Number of enrolments of both sexes of Secondary general in 1982?
Provide a succinct answer. 4.39e+05. What is the difference between the Number of enrolments of both sexes in Primary in 1978 and the Number of enrolments of both sexes in Secondary vocational in 1982?
Provide a short and direct response. 5.85e+05. What is the difference between the Number of enrolments of both sexes of Secondary in 1978 and the Number of enrolments of both sexes of Secondary general in 1982?
Provide a succinct answer. -3.62e+04. What is the difference between the Number of enrolments of both sexes of Secondary in 1978 and the Number of enrolments of both sexes of Secondary vocational in 1982?
Ensure brevity in your answer.  1.10e+05. What is the difference between the Number of enrolments of both sexes of Secondary general in 1978 and the Number of enrolments of both sexes of Secondary vocational in 1982?
Give a very brief answer. 1.02e+05. What is the difference between the Number of enrolments of both sexes in Primary in 1978 and the Number of enrolments of both sexes in Secondary in 1983?
Your response must be concise. 4.23e+05. What is the difference between the Number of enrolments of both sexes of Primary in 1978 and the Number of enrolments of both sexes of Secondary general in 1983?
Your answer should be very brief. 4.35e+05. What is the difference between the Number of enrolments of both sexes of Primary in 1978 and the Number of enrolments of both sexes of Secondary vocational in 1983?
Give a very brief answer. 5.85e+05. What is the difference between the Number of enrolments of both sexes of Secondary in 1978 and the Number of enrolments of both sexes of Secondary general in 1983?
Make the answer very short. -4.04e+04. What is the difference between the Number of enrolments of both sexes in Secondary in 1978 and the Number of enrolments of both sexes in Secondary vocational in 1983?
Offer a terse response. 1.10e+05. What is the difference between the Number of enrolments of both sexes of Secondary general in 1978 and the Number of enrolments of both sexes of Secondary vocational in 1983?
Provide a succinct answer. 1.02e+05. What is the difference between the Number of enrolments of both sexes of Primary in 1979 and the Number of enrolments of both sexes of Secondary in 1980?
Keep it short and to the point. 4.73e+05. What is the difference between the Number of enrolments of both sexes in Primary in 1979 and the Number of enrolments of both sexes in Secondary general in 1980?
Ensure brevity in your answer.  4.83e+05. What is the difference between the Number of enrolments of both sexes in Primary in 1979 and the Number of enrolments of both sexes in Secondary vocational in 1980?
Provide a short and direct response. 6.10e+05. What is the difference between the Number of enrolments of both sexes in Secondary in 1979 and the Number of enrolments of both sexes in Secondary general in 1980?
Offer a very short reply. 2023. What is the difference between the Number of enrolments of both sexes of Secondary in 1979 and the Number of enrolments of both sexes of Secondary vocational in 1980?
Your response must be concise. 1.29e+05. What is the difference between the Number of enrolments of both sexes in Secondary general in 1979 and the Number of enrolments of both sexes in Secondary vocational in 1980?
Your answer should be very brief. 1.08e+05. What is the difference between the Number of enrolments of both sexes of Primary in 1979 and the Number of enrolments of both sexes of Secondary in 1981?
Ensure brevity in your answer.  4.62e+05. What is the difference between the Number of enrolments of both sexes in Primary in 1979 and the Number of enrolments of both sexes in Secondary general in 1981?
Provide a succinct answer. 4.75e+05. What is the difference between the Number of enrolments of both sexes of Primary in 1979 and the Number of enrolments of both sexes of Secondary vocational in 1981?
Provide a succinct answer. 6.10e+05. What is the difference between the Number of enrolments of both sexes of Secondary in 1979 and the Number of enrolments of both sexes of Secondary general in 1981?
Your answer should be compact. -5648. What is the difference between the Number of enrolments of both sexes of Secondary in 1979 and the Number of enrolments of both sexes of Secondary vocational in 1981?
Keep it short and to the point. 1.29e+05. What is the difference between the Number of enrolments of both sexes in Secondary general in 1979 and the Number of enrolments of both sexes in Secondary vocational in 1981?
Provide a short and direct response. 1.08e+05. What is the difference between the Number of enrolments of both sexes in Primary in 1979 and the Number of enrolments of both sexes in Secondary in 1982?
Your answer should be compact. 4.58e+05. What is the difference between the Number of enrolments of both sexes in Primary in 1979 and the Number of enrolments of both sexes in Secondary general in 1982?
Provide a short and direct response. 4.64e+05. What is the difference between the Number of enrolments of both sexes of Primary in 1979 and the Number of enrolments of both sexes of Secondary vocational in 1982?
Your answer should be very brief. 6.10e+05. What is the difference between the Number of enrolments of both sexes in Secondary in 1979 and the Number of enrolments of both sexes in Secondary general in 1982?
Make the answer very short. -1.67e+04. What is the difference between the Number of enrolments of both sexes of Secondary in 1979 and the Number of enrolments of both sexes of Secondary vocational in 1982?
Ensure brevity in your answer.  1.29e+05. What is the difference between the Number of enrolments of both sexes of Secondary general in 1979 and the Number of enrolments of both sexes of Secondary vocational in 1982?
Keep it short and to the point. 1.08e+05. What is the difference between the Number of enrolments of both sexes in Primary in 1979 and the Number of enrolments of both sexes in Secondary in 1983?
Your answer should be compact. 4.49e+05. What is the difference between the Number of enrolments of both sexes of Primary in 1979 and the Number of enrolments of both sexes of Secondary general in 1983?
Your answer should be compact. 4.60e+05. What is the difference between the Number of enrolments of both sexes in Primary in 1979 and the Number of enrolments of both sexes in Secondary vocational in 1983?
Your answer should be compact. 6.10e+05. What is the difference between the Number of enrolments of both sexes in Secondary in 1979 and the Number of enrolments of both sexes in Secondary general in 1983?
Keep it short and to the point. -2.09e+04. What is the difference between the Number of enrolments of both sexes of Secondary in 1979 and the Number of enrolments of both sexes of Secondary vocational in 1983?
Give a very brief answer. 1.29e+05. What is the difference between the Number of enrolments of both sexes in Secondary general in 1979 and the Number of enrolments of both sexes in Secondary vocational in 1983?
Keep it short and to the point. 1.08e+05. What is the difference between the Number of enrolments of both sexes in Primary in 1980 and the Number of enrolments of both sexes in Secondary in 1981?
Ensure brevity in your answer.  5.18e+05. What is the difference between the Number of enrolments of both sexes of Primary in 1980 and the Number of enrolments of both sexes of Secondary general in 1981?
Ensure brevity in your answer.  5.31e+05. What is the difference between the Number of enrolments of both sexes of Primary in 1980 and the Number of enrolments of both sexes of Secondary vocational in 1981?
Ensure brevity in your answer.  6.65e+05. What is the difference between the Number of enrolments of both sexes in Secondary in 1980 and the Number of enrolments of both sexes in Secondary general in 1981?
Your response must be concise. 1875. What is the difference between the Number of enrolments of both sexes in Secondary in 1980 and the Number of enrolments of both sexes in Secondary vocational in 1981?
Make the answer very short. 1.37e+05. What is the difference between the Number of enrolments of both sexes of Secondary general in 1980 and the Number of enrolments of both sexes of Secondary vocational in 1981?
Provide a succinct answer. 1.27e+05. What is the difference between the Number of enrolments of both sexes of Primary in 1980 and the Number of enrolments of both sexes of Secondary in 1982?
Provide a succinct answer. 5.14e+05. What is the difference between the Number of enrolments of both sexes of Primary in 1980 and the Number of enrolments of both sexes of Secondary general in 1982?
Offer a very short reply. 5.20e+05. What is the difference between the Number of enrolments of both sexes of Primary in 1980 and the Number of enrolments of both sexes of Secondary vocational in 1982?
Give a very brief answer. 6.65e+05. What is the difference between the Number of enrolments of both sexes of Secondary in 1980 and the Number of enrolments of both sexes of Secondary general in 1982?
Keep it short and to the point. -9146. What is the difference between the Number of enrolments of both sexes of Secondary in 1980 and the Number of enrolments of both sexes of Secondary vocational in 1982?
Your answer should be very brief. 1.37e+05. What is the difference between the Number of enrolments of both sexes in Secondary general in 1980 and the Number of enrolments of both sexes in Secondary vocational in 1982?
Ensure brevity in your answer.  1.27e+05. What is the difference between the Number of enrolments of both sexes in Primary in 1980 and the Number of enrolments of both sexes in Secondary in 1983?
Your answer should be compact. 5.04e+05. What is the difference between the Number of enrolments of both sexes of Primary in 1980 and the Number of enrolments of both sexes of Secondary general in 1983?
Ensure brevity in your answer.  5.15e+05. What is the difference between the Number of enrolments of both sexes in Primary in 1980 and the Number of enrolments of both sexes in Secondary vocational in 1983?
Your answer should be compact. 6.66e+05. What is the difference between the Number of enrolments of both sexes of Secondary in 1980 and the Number of enrolments of both sexes of Secondary general in 1983?
Give a very brief answer. -1.34e+04. What is the difference between the Number of enrolments of both sexes in Secondary in 1980 and the Number of enrolments of both sexes in Secondary vocational in 1983?
Make the answer very short. 1.37e+05. What is the difference between the Number of enrolments of both sexes of Secondary general in 1980 and the Number of enrolments of both sexes of Secondary vocational in 1983?
Provide a short and direct response. 1.27e+05. What is the difference between the Number of enrolments of both sexes of Primary in 1981 and the Number of enrolments of both sexes of Secondary in 1982?
Your answer should be very brief. 5.38e+05. What is the difference between the Number of enrolments of both sexes of Primary in 1981 and the Number of enrolments of both sexes of Secondary general in 1982?
Offer a terse response. 5.44e+05. What is the difference between the Number of enrolments of both sexes of Primary in 1981 and the Number of enrolments of both sexes of Secondary vocational in 1982?
Ensure brevity in your answer.  6.89e+05. What is the difference between the Number of enrolments of both sexes in Secondary in 1981 and the Number of enrolments of both sexes in Secondary general in 1982?
Your answer should be very brief. 1888. What is the difference between the Number of enrolments of both sexes in Secondary in 1981 and the Number of enrolments of both sexes in Secondary vocational in 1982?
Provide a short and direct response. 1.48e+05. What is the difference between the Number of enrolments of both sexes in Secondary general in 1981 and the Number of enrolments of both sexes in Secondary vocational in 1982?
Your answer should be compact. 1.35e+05. What is the difference between the Number of enrolments of both sexes in Primary in 1981 and the Number of enrolments of both sexes in Secondary in 1983?
Keep it short and to the point. 5.28e+05. What is the difference between the Number of enrolments of both sexes of Primary in 1981 and the Number of enrolments of both sexes of Secondary general in 1983?
Ensure brevity in your answer.  5.39e+05. What is the difference between the Number of enrolments of both sexes in Primary in 1981 and the Number of enrolments of both sexes in Secondary vocational in 1983?
Offer a very short reply. 6.90e+05. What is the difference between the Number of enrolments of both sexes in Secondary in 1981 and the Number of enrolments of both sexes in Secondary general in 1983?
Provide a succinct answer. -2333. What is the difference between the Number of enrolments of both sexes in Secondary in 1981 and the Number of enrolments of both sexes in Secondary vocational in 1983?
Your answer should be very brief. 1.48e+05. What is the difference between the Number of enrolments of both sexes of Secondary general in 1981 and the Number of enrolments of both sexes of Secondary vocational in 1983?
Provide a succinct answer. 1.35e+05. What is the difference between the Number of enrolments of both sexes of Primary in 1982 and the Number of enrolments of both sexes of Secondary in 1983?
Provide a succinct answer. 5.91e+05. What is the difference between the Number of enrolments of both sexes of Primary in 1982 and the Number of enrolments of both sexes of Secondary general in 1983?
Keep it short and to the point. 6.03e+05. What is the difference between the Number of enrolments of both sexes in Primary in 1982 and the Number of enrolments of both sexes in Secondary vocational in 1983?
Provide a short and direct response. 7.53e+05. What is the difference between the Number of enrolments of both sexes in Secondary in 1982 and the Number of enrolments of both sexes in Secondary general in 1983?
Ensure brevity in your answer.  1814. What is the difference between the Number of enrolments of both sexes in Secondary in 1982 and the Number of enrolments of both sexes in Secondary vocational in 1983?
Your response must be concise. 1.52e+05. What is the difference between the Number of enrolments of both sexes in Secondary general in 1982 and the Number of enrolments of both sexes in Secondary vocational in 1983?
Give a very brief answer. 1.46e+05. What is the average Number of enrolments of both sexes in Primary per year?
Offer a very short reply. 6.50e+05. What is the average Number of enrolments of both sexes in Secondary per year?
Keep it short and to the point. 1.31e+05. What is the average Number of enrolments of both sexes in Secondary general per year?
Your answer should be very brief. 1.20e+05. What is the average Number of enrolments of both sexes in Secondary vocational per year?
Your response must be concise. 1812.5. In the year 1976, what is the difference between the Number of enrolments of both sexes in Primary and Number of enrolments of both sexes in Secondary?
Provide a succinct answer. 4.74e+05. In the year 1976, what is the difference between the Number of enrolments of both sexes in Primary and Number of enrolments of both sexes in Secondary general?
Provide a succinct answer. 4.87e+05. In the year 1976, what is the difference between the Number of enrolments of both sexes in Primary and Number of enrolments of both sexes in Secondary vocational?
Make the answer very short. 5.70e+05. In the year 1976, what is the difference between the Number of enrolments of both sexes of Secondary and Number of enrolments of both sexes of Secondary general?
Give a very brief answer. 1.23e+04. In the year 1976, what is the difference between the Number of enrolments of both sexes of Secondary and Number of enrolments of both sexes of Secondary vocational?
Your response must be concise. 9.57e+04. In the year 1976, what is the difference between the Number of enrolments of both sexes in Secondary general and Number of enrolments of both sexes in Secondary vocational?
Offer a terse response. 8.34e+04. In the year 1977, what is the difference between the Number of enrolments of both sexes in Primary and Number of enrolments of both sexes in Secondary?
Provide a succinct answer. 4.77e+05. In the year 1977, what is the difference between the Number of enrolments of both sexes in Primary and Number of enrolments of both sexes in Secondary general?
Provide a short and direct response. 4.87e+05. In the year 1977, what is the difference between the Number of enrolments of both sexes in Primary and Number of enrolments of both sexes in Secondary vocational?
Your response must be concise. 5.81e+05. In the year 1977, what is the difference between the Number of enrolments of both sexes of Secondary and Number of enrolments of both sexes of Secondary general?
Offer a very short reply. 1.03e+04. In the year 1977, what is the difference between the Number of enrolments of both sexes of Secondary and Number of enrolments of both sexes of Secondary vocational?
Provide a short and direct response. 1.04e+05. In the year 1977, what is the difference between the Number of enrolments of both sexes of Secondary general and Number of enrolments of both sexes of Secondary vocational?
Provide a short and direct response. 9.38e+04. In the year 1978, what is the difference between the Number of enrolments of both sexes of Primary and Number of enrolments of both sexes of Secondary?
Offer a terse response. 4.75e+05. In the year 1978, what is the difference between the Number of enrolments of both sexes in Primary and Number of enrolments of both sexes in Secondary general?
Make the answer very short. 4.83e+05. In the year 1978, what is the difference between the Number of enrolments of both sexes in Primary and Number of enrolments of both sexes in Secondary vocational?
Give a very brief answer. 5.85e+05. In the year 1978, what is the difference between the Number of enrolments of both sexes of Secondary and Number of enrolments of both sexes of Secondary general?
Provide a short and direct response. 7326. In the year 1978, what is the difference between the Number of enrolments of both sexes in Secondary and Number of enrolments of both sexes in Secondary vocational?
Your response must be concise. 1.10e+05. In the year 1978, what is the difference between the Number of enrolments of both sexes in Secondary general and Number of enrolments of both sexes in Secondary vocational?
Offer a very short reply. 1.02e+05. In the year 1979, what is the difference between the Number of enrolments of both sexes of Primary and Number of enrolments of both sexes of Secondary?
Your answer should be very brief. 4.81e+05. In the year 1979, what is the difference between the Number of enrolments of both sexes in Primary and Number of enrolments of both sexes in Secondary general?
Your answer should be compact. 5.02e+05. In the year 1979, what is the difference between the Number of enrolments of both sexes in Primary and Number of enrolments of both sexes in Secondary vocational?
Your answer should be compact. 6.10e+05. In the year 1979, what is the difference between the Number of enrolments of both sexes in Secondary and Number of enrolments of both sexes in Secondary general?
Ensure brevity in your answer.  2.14e+04. In the year 1979, what is the difference between the Number of enrolments of both sexes of Secondary and Number of enrolments of both sexes of Secondary vocational?
Your answer should be compact. 1.29e+05. In the year 1979, what is the difference between the Number of enrolments of both sexes of Secondary general and Number of enrolments of both sexes of Secondary vocational?
Keep it short and to the point. 1.08e+05. In the year 1980, what is the difference between the Number of enrolments of both sexes of Primary and Number of enrolments of both sexes of Secondary?
Provide a succinct answer. 5.29e+05. In the year 1980, what is the difference between the Number of enrolments of both sexes in Primary and Number of enrolments of both sexes in Secondary general?
Provide a succinct answer. 5.38e+05. In the year 1980, what is the difference between the Number of enrolments of both sexes of Primary and Number of enrolments of both sexes of Secondary vocational?
Provide a succinct answer. 6.65e+05. In the year 1980, what is the difference between the Number of enrolments of both sexes in Secondary and Number of enrolments of both sexes in Secondary general?
Offer a very short reply. 9546. In the year 1980, what is the difference between the Number of enrolments of both sexes of Secondary and Number of enrolments of both sexes of Secondary vocational?
Your response must be concise. 1.37e+05. In the year 1980, what is the difference between the Number of enrolments of both sexes of Secondary general and Number of enrolments of both sexes of Secondary vocational?
Provide a succinct answer. 1.27e+05. In the year 1981, what is the difference between the Number of enrolments of both sexes in Primary and Number of enrolments of both sexes in Secondary?
Make the answer very short. 5.42e+05. In the year 1981, what is the difference between the Number of enrolments of both sexes in Primary and Number of enrolments of both sexes in Secondary general?
Keep it short and to the point. 5.55e+05. In the year 1981, what is the difference between the Number of enrolments of both sexes of Primary and Number of enrolments of both sexes of Secondary vocational?
Your response must be concise. 6.89e+05. In the year 1981, what is the difference between the Number of enrolments of both sexes in Secondary and Number of enrolments of both sexes in Secondary general?
Offer a terse response. 1.29e+04. In the year 1981, what is the difference between the Number of enrolments of both sexes in Secondary and Number of enrolments of both sexes in Secondary vocational?
Provide a succinct answer. 1.48e+05. In the year 1981, what is the difference between the Number of enrolments of both sexes in Secondary general and Number of enrolments of both sexes in Secondary vocational?
Ensure brevity in your answer.  1.35e+05. In the year 1982, what is the difference between the Number of enrolments of both sexes of Primary and Number of enrolments of both sexes of Secondary?
Offer a very short reply. 6.01e+05. In the year 1982, what is the difference between the Number of enrolments of both sexes of Primary and Number of enrolments of both sexes of Secondary general?
Offer a terse response. 6.07e+05. In the year 1982, what is the difference between the Number of enrolments of both sexes of Primary and Number of enrolments of both sexes of Secondary vocational?
Make the answer very short. 7.53e+05. In the year 1982, what is the difference between the Number of enrolments of both sexes of Secondary and Number of enrolments of both sexes of Secondary general?
Give a very brief answer. 6035. In the year 1982, what is the difference between the Number of enrolments of both sexes of Secondary and Number of enrolments of both sexes of Secondary vocational?
Your response must be concise. 1.52e+05. In the year 1982, what is the difference between the Number of enrolments of both sexes in Secondary general and Number of enrolments of both sexes in Secondary vocational?
Offer a very short reply. 1.46e+05. In the year 1983, what is the difference between the Number of enrolments of both sexes of Primary and Number of enrolments of both sexes of Secondary?
Offer a terse response. 5.73e+05. In the year 1983, what is the difference between the Number of enrolments of both sexes in Primary and Number of enrolments of both sexes in Secondary general?
Provide a succinct answer. 5.85e+05. In the year 1983, what is the difference between the Number of enrolments of both sexes in Primary and Number of enrolments of both sexes in Secondary vocational?
Give a very brief answer. 7.35e+05. In the year 1983, what is the difference between the Number of enrolments of both sexes of Secondary and Number of enrolments of both sexes of Secondary general?
Your answer should be very brief. 1.15e+04. In the year 1983, what is the difference between the Number of enrolments of both sexes of Secondary and Number of enrolments of both sexes of Secondary vocational?
Give a very brief answer. 1.62e+05. In the year 1983, what is the difference between the Number of enrolments of both sexes of Secondary general and Number of enrolments of both sexes of Secondary vocational?
Ensure brevity in your answer.  1.50e+05. What is the ratio of the Number of enrolments of both sexes in Secondary in 1976 to that in 1977?
Offer a terse response. 0.92. What is the ratio of the Number of enrolments of both sexes of Secondary general in 1976 to that in 1977?
Keep it short and to the point. 0.89. What is the ratio of the Number of enrolments of both sexes of Secondary vocational in 1976 to that in 1977?
Give a very brief answer. 0.73. What is the ratio of the Number of enrolments of both sexes of Primary in 1976 to that in 1978?
Offer a very short reply. 0.97. What is the ratio of the Number of enrolments of both sexes in Secondary in 1976 to that in 1978?
Provide a succinct answer. 0.87. What is the ratio of the Number of enrolments of both sexes of Secondary general in 1976 to that in 1978?
Your response must be concise. 0.81. What is the ratio of the Number of enrolments of both sexes of Secondary vocational in 1976 to that in 1978?
Your answer should be compact. 0.73. What is the ratio of the Number of enrolments of both sexes of Primary in 1976 to that in 1979?
Your answer should be compact. 0.93. What is the ratio of the Number of enrolments of both sexes in Secondary in 1976 to that in 1979?
Provide a succinct answer. 0.74. What is the ratio of the Number of enrolments of both sexes of Secondary general in 1976 to that in 1979?
Give a very brief answer. 0.77. What is the ratio of the Number of enrolments of both sexes in Secondary vocational in 1976 to that in 1979?
Provide a succinct answer. 0.69. What is the ratio of the Number of enrolments of both sexes of Primary in 1976 to that in 1980?
Your answer should be very brief. 0.86. What is the ratio of the Number of enrolments of both sexes of Secondary in 1976 to that in 1980?
Ensure brevity in your answer.  0.7. What is the ratio of the Number of enrolments of both sexes of Secondary general in 1976 to that in 1980?
Your answer should be compact. 0.66. What is the ratio of the Number of enrolments of both sexes of Secondary vocational in 1976 to that in 1980?
Your response must be concise. 0.74. What is the ratio of the Number of enrolments of both sexes in Primary in 1976 to that in 1981?
Offer a terse response. 0.83. What is the ratio of the Number of enrolments of both sexes in Secondary in 1976 to that in 1981?
Give a very brief answer. 0.65. What is the ratio of the Number of enrolments of both sexes of Secondary general in 1976 to that in 1981?
Provide a short and direct response. 0.62. What is the ratio of the Number of enrolments of both sexes in Secondary vocational in 1976 to that in 1981?
Give a very brief answer. 0.74. What is the ratio of the Number of enrolments of both sexes of Primary in 1976 to that in 1982?
Your answer should be compact. 0.76. What is the ratio of the Number of enrolments of both sexes in Secondary in 1976 to that in 1982?
Keep it short and to the point. 0.63. What is the ratio of the Number of enrolments of both sexes in Secondary general in 1976 to that in 1982?
Offer a very short reply. 0.57. What is the ratio of the Number of enrolments of both sexes in Secondary vocational in 1976 to that in 1982?
Provide a short and direct response. 0.77. What is the ratio of the Number of enrolments of both sexes of Primary in 1976 to that in 1983?
Provide a succinct answer. 0.78. What is the ratio of the Number of enrolments of both sexes in Secondary in 1976 to that in 1983?
Provide a succinct answer. 0.59. What is the ratio of the Number of enrolments of both sexes of Secondary general in 1976 to that in 1983?
Provide a short and direct response. 0.56. What is the ratio of the Number of enrolments of both sexes of Secondary vocational in 1976 to that in 1983?
Your answer should be compact. 0.82. What is the ratio of the Number of enrolments of both sexes in Secondary in 1977 to that in 1978?
Provide a succinct answer. 0.95. What is the ratio of the Number of enrolments of both sexes in Secondary general in 1977 to that in 1978?
Give a very brief answer. 0.92. What is the ratio of the Number of enrolments of both sexes in Primary in 1977 to that in 1979?
Offer a very short reply. 0.95. What is the ratio of the Number of enrolments of both sexes in Secondary in 1977 to that in 1979?
Your answer should be compact. 0.81. What is the ratio of the Number of enrolments of both sexes in Secondary general in 1977 to that in 1979?
Offer a very short reply. 0.87. What is the ratio of the Number of enrolments of both sexes in Secondary vocational in 1977 to that in 1979?
Ensure brevity in your answer.  0.94. What is the ratio of the Number of enrolments of both sexes of Primary in 1977 to that in 1980?
Your answer should be compact. 0.87. What is the ratio of the Number of enrolments of both sexes in Secondary in 1977 to that in 1980?
Give a very brief answer. 0.77. What is the ratio of the Number of enrolments of both sexes in Secondary general in 1977 to that in 1980?
Ensure brevity in your answer.  0.74. What is the ratio of the Number of enrolments of both sexes of Secondary vocational in 1977 to that in 1980?
Give a very brief answer. 1.02. What is the ratio of the Number of enrolments of both sexes of Primary in 1977 to that in 1981?
Your answer should be compact. 0.84. What is the ratio of the Number of enrolments of both sexes in Secondary in 1977 to that in 1981?
Offer a terse response. 0.71. What is the ratio of the Number of enrolments of both sexes of Secondary general in 1977 to that in 1981?
Make the answer very short. 0.7. What is the ratio of the Number of enrolments of both sexes of Primary in 1977 to that in 1982?
Make the answer very short. 0.77. What is the ratio of the Number of enrolments of both sexes of Secondary in 1977 to that in 1982?
Your answer should be compact. 0.69. What is the ratio of the Number of enrolments of both sexes of Secondary general in 1977 to that in 1982?
Provide a short and direct response. 0.65. What is the ratio of the Number of enrolments of both sexes in Secondary vocational in 1977 to that in 1982?
Give a very brief answer. 1.05. What is the ratio of the Number of enrolments of both sexes in Primary in 1977 to that in 1983?
Your response must be concise. 0.79. What is the ratio of the Number of enrolments of both sexes of Secondary in 1977 to that in 1983?
Provide a succinct answer. 0.65. What is the ratio of the Number of enrolments of both sexes of Secondary general in 1977 to that in 1983?
Your answer should be very brief. 0.63. What is the ratio of the Number of enrolments of both sexes of Secondary vocational in 1977 to that in 1983?
Your answer should be compact. 1.13. What is the ratio of the Number of enrolments of both sexes of Primary in 1978 to that in 1979?
Provide a succinct answer. 0.96. What is the ratio of the Number of enrolments of both sexes in Secondary in 1978 to that in 1979?
Ensure brevity in your answer.  0.85. What is the ratio of the Number of enrolments of both sexes of Secondary general in 1978 to that in 1979?
Give a very brief answer. 0.95. What is the ratio of the Number of enrolments of both sexes in Secondary vocational in 1978 to that in 1979?
Give a very brief answer. 0.95. What is the ratio of the Number of enrolments of both sexes in Primary in 1978 to that in 1980?
Your answer should be very brief. 0.88. What is the ratio of the Number of enrolments of both sexes in Secondary in 1978 to that in 1980?
Provide a succinct answer. 0.8. What is the ratio of the Number of enrolments of both sexes of Secondary general in 1978 to that in 1980?
Your answer should be compact. 0.81. What is the ratio of the Number of enrolments of both sexes in Secondary vocational in 1978 to that in 1980?
Give a very brief answer. 1.02. What is the ratio of the Number of enrolments of both sexes in Primary in 1978 to that in 1981?
Offer a terse response. 0.85. What is the ratio of the Number of enrolments of both sexes in Secondary in 1978 to that in 1981?
Your answer should be very brief. 0.75. What is the ratio of the Number of enrolments of both sexes in Secondary general in 1978 to that in 1981?
Keep it short and to the point. 0.76. What is the ratio of the Number of enrolments of both sexes in Secondary vocational in 1978 to that in 1981?
Give a very brief answer. 1.01. What is the ratio of the Number of enrolments of both sexes of Primary in 1978 to that in 1982?
Your answer should be very brief. 0.78. What is the ratio of the Number of enrolments of both sexes of Secondary in 1978 to that in 1982?
Ensure brevity in your answer.  0.73. What is the ratio of the Number of enrolments of both sexes of Secondary general in 1978 to that in 1982?
Your answer should be compact. 0.71. What is the ratio of the Number of enrolments of both sexes of Secondary vocational in 1978 to that in 1982?
Give a very brief answer. 1.06. What is the ratio of the Number of enrolments of both sexes of Primary in 1978 to that in 1983?
Provide a short and direct response. 0.8. What is the ratio of the Number of enrolments of both sexes in Secondary in 1978 to that in 1983?
Make the answer very short. 0.68. What is the ratio of the Number of enrolments of both sexes of Secondary general in 1978 to that in 1983?
Offer a very short reply. 0.69. What is the ratio of the Number of enrolments of both sexes of Secondary vocational in 1978 to that in 1983?
Your answer should be compact. 1.13. What is the ratio of the Number of enrolments of both sexes in Primary in 1979 to that in 1980?
Your answer should be very brief. 0.92. What is the ratio of the Number of enrolments of both sexes of Secondary in 1979 to that in 1980?
Give a very brief answer. 0.95. What is the ratio of the Number of enrolments of both sexes in Secondary general in 1979 to that in 1980?
Ensure brevity in your answer.  0.85. What is the ratio of the Number of enrolments of both sexes of Secondary vocational in 1979 to that in 1980?
Offer a terse response. 1.08. What is the ratio of the Number of enrolments of both sexes of Primary in 1979 to that in 1981?
Offer a very short reply. 0.89. What is the ratio of the Number of enrolments of both sexes in Secondary in 1979 to that in 1981?
Offer a very short reply. 0.88. What is the ratio of the Number of enrolments of both sexes in Secondary general in 1979 to that in 1981?
Your answer should be compact. 0.8. What is the ratio of the Number of enrolments of both sexes in Secondary vocational in 1979 to that in 1981?
Provide a succinct answer. 1.07. What is the ratio of the Number of enrolments of both sexes in Primary in 1979 to that in 1982?
Provide a succinct answer. 0.81. What is the ratio of the Number of enrolments of both sexes in Secondary in 1979 to that in 1982?
Make the answer very short. 0.85. What is the ratio of the Number of enrolments of both sexes in Secondary general in 1979 to that in 1982?
Keep it short and to the point. 0.74. What is the ratio of the Number of enrolments of both sexes in Secondary vocational in 1979 to that in 1982?
Provide a short and direct response. 1.12. What is the ratio of the Number of enrolments of both sexes in Primary in 1979 to that in 1983?
Make the answer very short. 0.83. What is the ratio of the Number of enrolments of both sexes in Secondary in 1979 to that in 1983?
Ensure brevity in your answer.  0.8. What is the ratio of the Number of enrolments of both sexes in Secondary general in 1979 to that in 1983?
Give a very brief answer. 0.72. What is the ratio of the Number of enrolments of both sexes in Secondary vocational in 1979 to that in 1983?
Make the answer very short. 1.2. What is the ratio of the Number of enrolments of both sexes in Primary in 1980 to that in 1981?
Keep it short and to the point. 0.97. What is the ratio of the Number of enrolments of both sexes of Secondary in 1980 to that in 1981?
Provide a succinct answer. 0.93. What is the ratio of the Number of enrolments of both sexes in Secondary general in 1980 to that in 1981?
Your response must be concise. 0.94. What is the ratio of the Number of enrolments of both sexes of Secondary vocational in 1980 to that in 1981?
Offer a terse response. 0.99. What is the ratio of the Number of enrolments of both sexes in Primary in 1980 to that in 1982?
Your response must be concise. 0.88. What is the ratio of the Number of enrolments of both sexes in Secondary in 1980 to that in 1982?
Provide a succinct answer. 0.9. What is the ratio of the Number of enrolments of both sexes in Secondary general in 1980 to that in 1982?
Ensure brevity in your answer.  0.87. What is the ratio of the Number of enrolments of both sexes of Secondary vocational in 1980 to that in 1982?
Provide a succinct answer. 1.03. What is the ratio of the Number of enrolments of both sexes of Primary in 1980 to that in 1983?
Make the answer very short. 0.91. What is the ratio of the Number of enrolments of both sexes in Secondary in 1980 to that in 1983?
Give a very brief answer. 0.85. What is the ratio of the Number of enrolments of both sexes in Secondary general in 1980 to that in 1983?
Offer a terse response. 0.85. What is the ratio of the Number of enrolments of both sexes of Secondary vocational in 1980 to that in 1983?
Your answer should be very brief. 1.11. What is the ratio of the Number of enrolments of both sexes of Primary in 1981 to that in 1982?
Offer a very short reply. 0.92. What is the ratio of the Number of enrolments of both sexes of Secondary general in 1981 to that in 1982?
Provide a short and direct response. 0.93. What is the ratio of the Number of enrolments of both sexes of Secondary vocational in 1981 to that in 1982?
Ensure brevity in your answer.  1.04. What is the ratio of the Number of enrolments of both sexes of Primary in 1981 to that in 1983?
Give a very brief answer. 0.94. What is the ratio of the Number of enrolments of both sexes in Secondary in 1981 to that in 1983?
Provide a succinct answer. 0.92. What is the ratio of the Number of enrolments of both sexes of Secondary general in 1981 to that in 1983?
Your response must be concise. 0.9. What is the ratio of the Number of enrolments of both sexes of Secondary vocational in 1981 to that in 1983?
Offer a very short reply. 1.12. What is the ratio of the Number of enrolments of both sexes in Primary in 1982 to that in 1983?
Offer a very short reply. 1.02. What is the ratio of the Number of enrolments of both sexes in Secondary in 1982 to that in 1983?
Make the answer very short. 0.94. What is the ratio of the Number of enrolments of both sexes of Secondary general in 1982 to that in 1983?
Your response must be concise. 0.97. What is the ratio of the Number of enrolments of both sexes in Secondary vocational in 1982 to that in 1983?
Keep it short and to the point. 1.07. What is the difference between the highest and the second highest Number of enrolments of both sexes of Primary?
Ensure brevity in your answer.  1.78e+04. What is the difference between the highest and the second highest Number of enrolments of both sexes in Secondary?
Ensure brevity in your answer.  9712. What is the difference between the highest and the second highest Number of enrolments of both sexes in Secondary general?
Make the answer very short. 4221. What is the difference between the highest and the second highest Number of enrolments of both sexes of Secondary vocational?
Make the answer very short. 108. What is the difference between the highest and the lowest Number of enrolments of both sexes in Primary?
Your response must be concise. 1.83e+05. What is the difference between the highest and the lowest Number of enrolments of both sexes of Secondary?
Your answer should be very brief. 6.63e+04. What is the difference between the highest and the lowest Number of enrolments of both sexes in Secondary general?
Offer a very short reply. 6.71e+04. What is the difference between the highest and the lowest Number of enrolments of both sexes of Secondary vocational?
Make the answer very short. 631. 